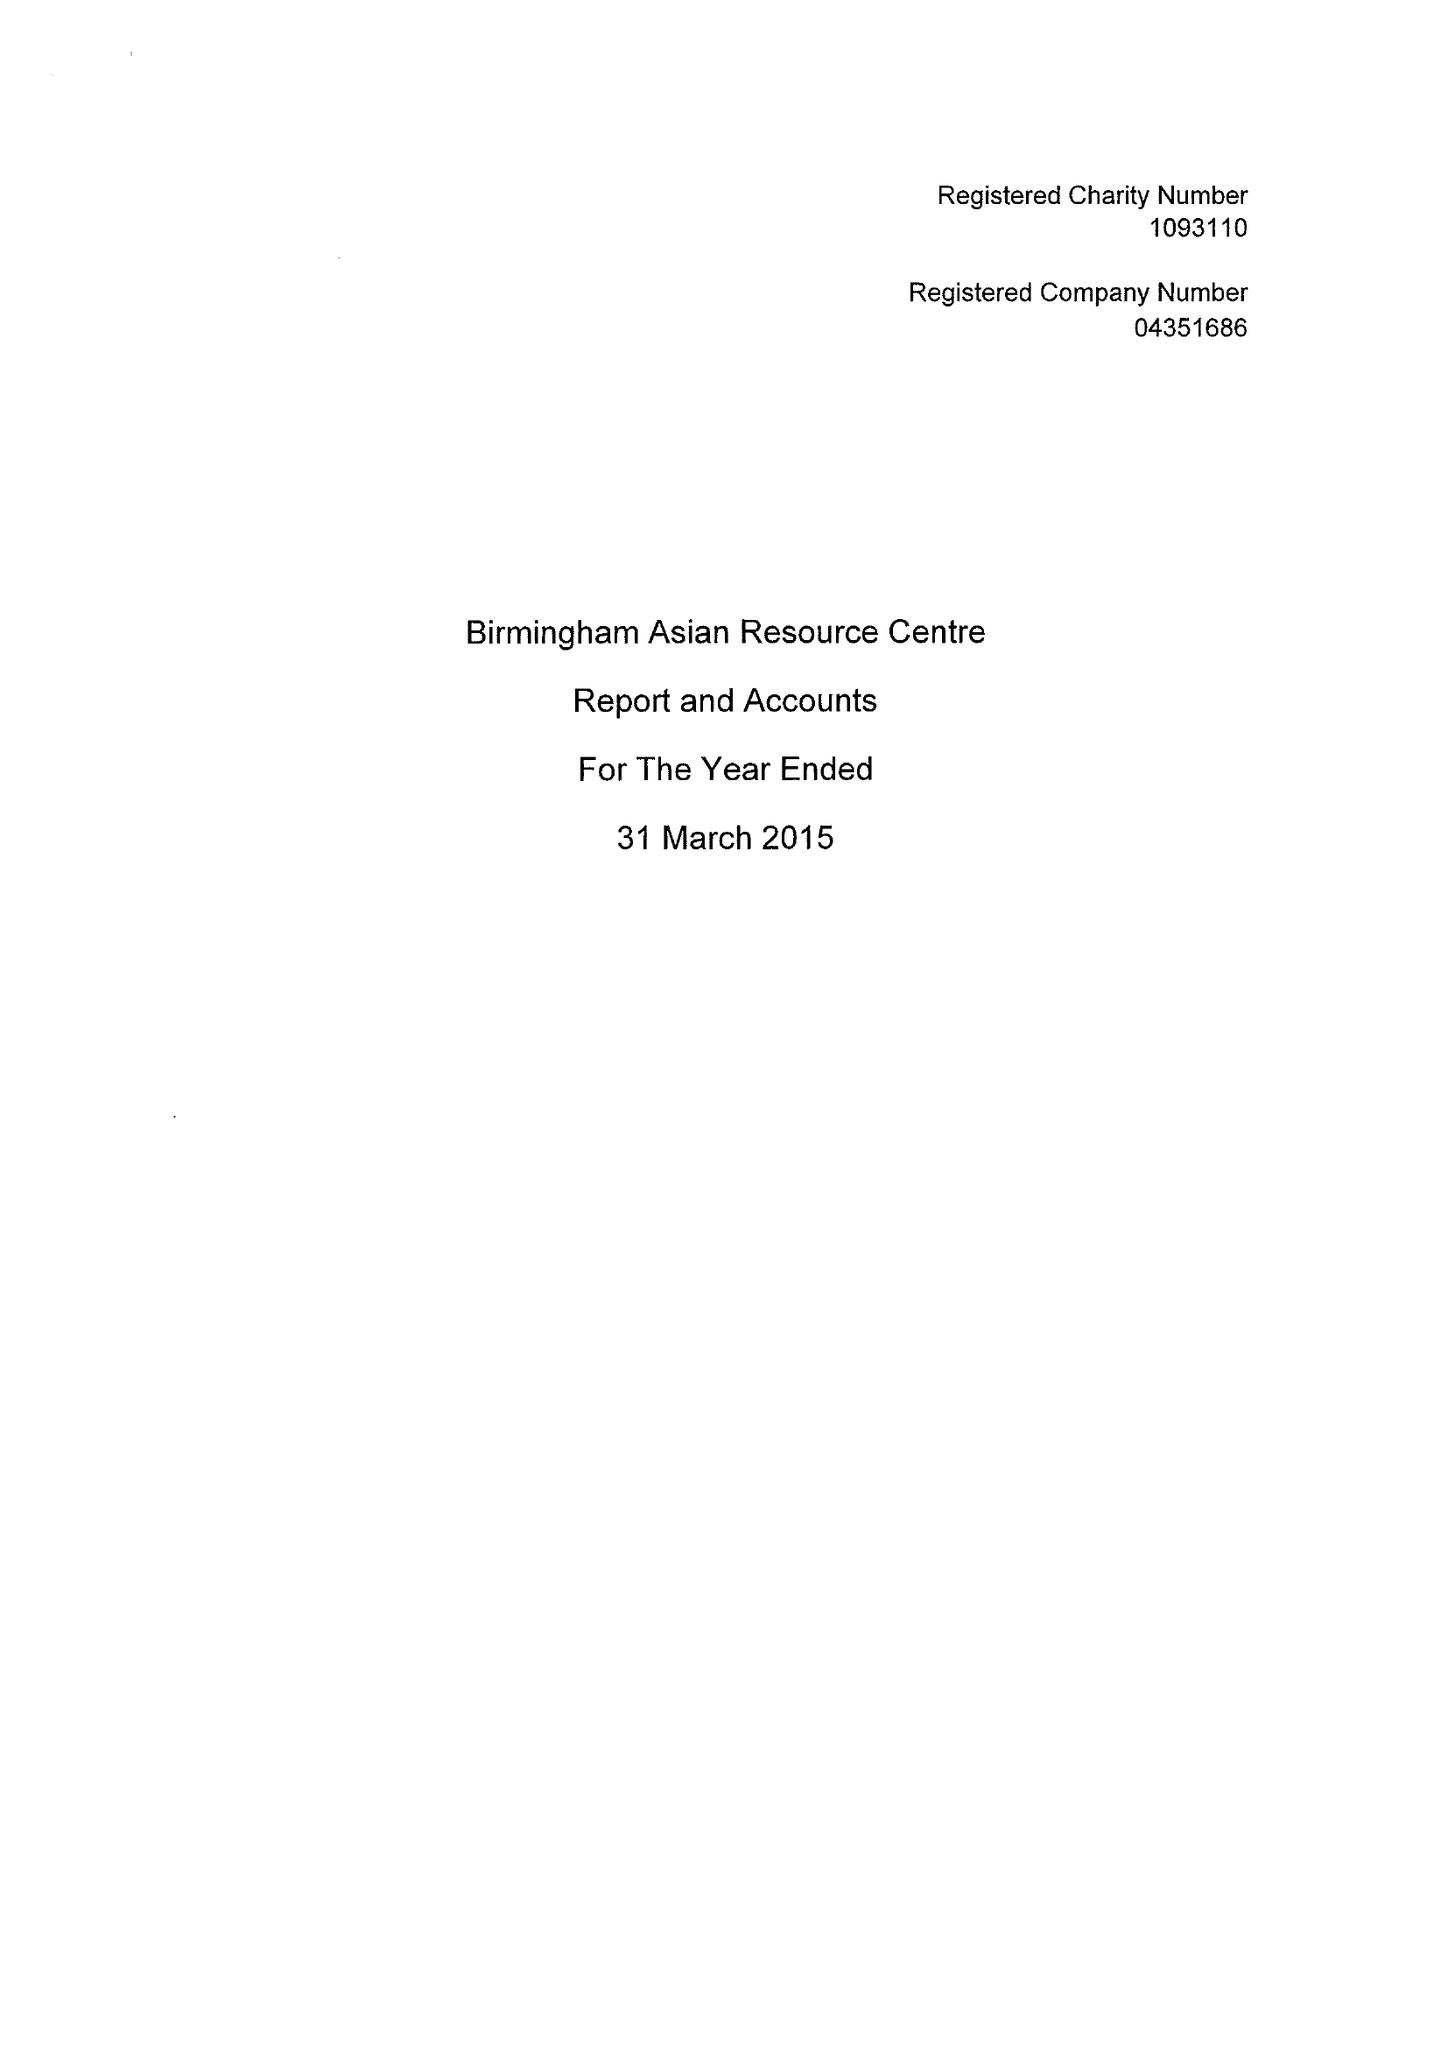What is the value for the address__street_line?
Answer the question using a single word or phrase. 110-114 HAMSTEAD ROAD 